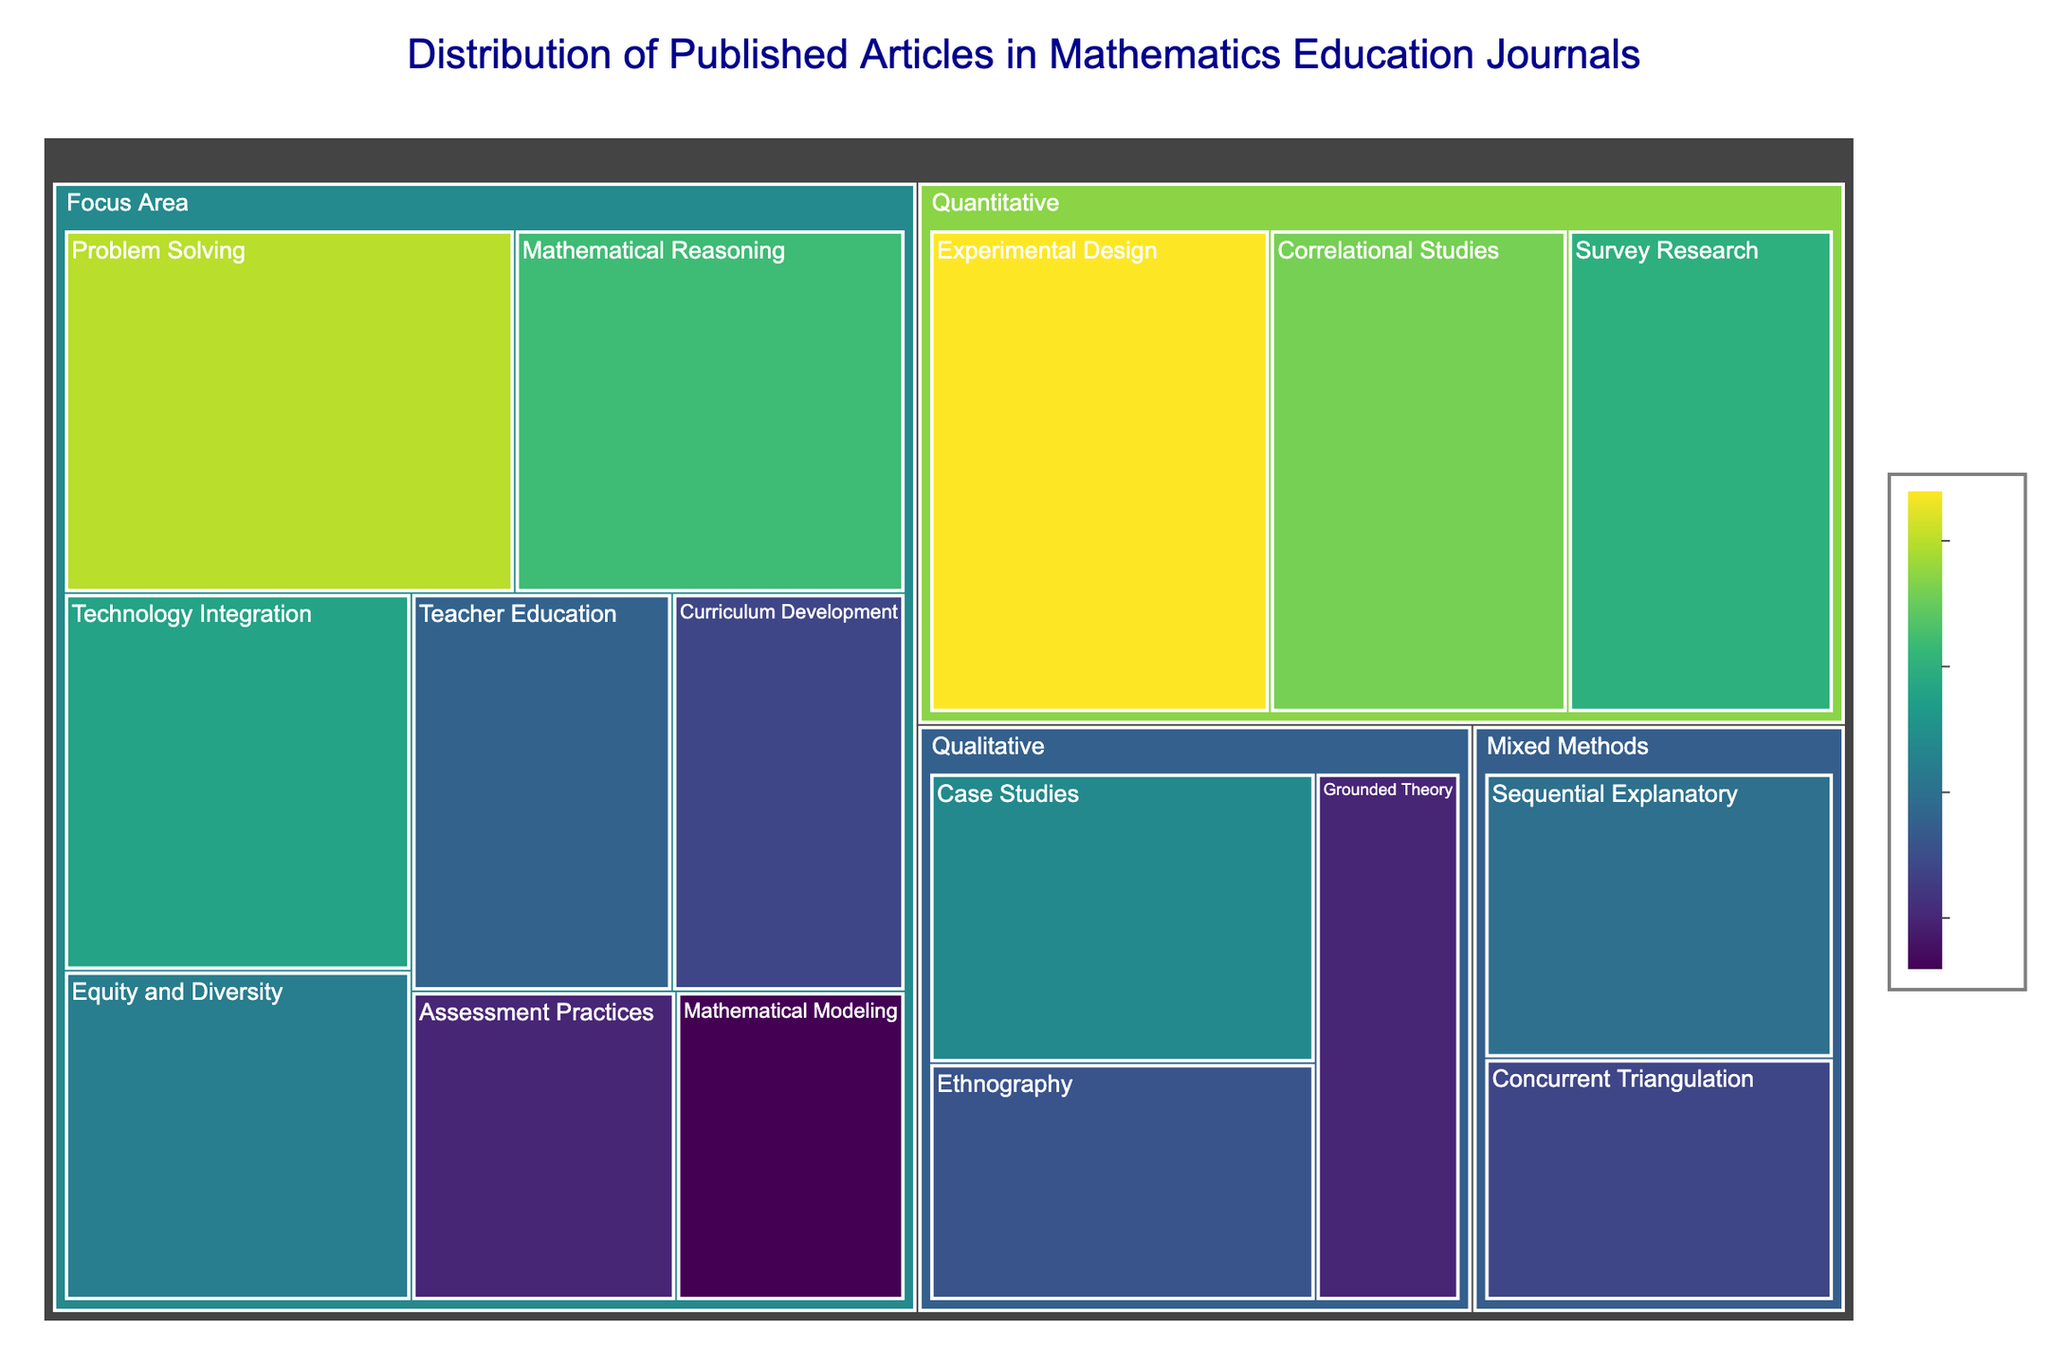What is the main title of the treemap? The main title is displayed at the top of the treemap in large font. It provides the overall description of the data presented.
Answer: Distribution of Published Articles in Mathematics Education Journals Which research methodology category has the highest number of published articles? By observing the segment size in the treemap, the category with the largest segment will have the highest number of articles.
Answer: Quantitative How many articles have been published in the "Case Studies" subcategory? Refer to the segment labeled "Case Studies" and check the number displayed.
Answer: 22 Which focus area has the least number of published articles? The focus area with the smallest segment will have the least number of articles.
Answer: Mathematical Modeling What is the combined total number of articles published in "Quantitative" research methodology subcategories? Sum values for all subcategories under Quantitative: 32 (Experimental Design) + 28 (Correlational Studies) + 25 (Survey Research).
Answer: 85 How many more articles are there in "Problem Solving" than in "Teacher Education"? Find the difference between the values for "Problem Solving" (30) and "Teacher Education" (19).
Answer: 11 Which subcategory under "Mixed Methods" has the highest number of published articles? Compare segment sizes under the Mixed Methods category to find the largest one.
Answer: Sequential Explanatory How does the number of articles in "Ethnography" compare to that in "Grounded Theory"? Check the values for "Ethnography" (18) and "Grounded Theory" (15), then determine which is higher.
Answer: Ethnography has 3 more articles than Grounded Theory What is the average number of articles published in the subcategories of "Qualitative" research methodology? Sum the values for categories under Qualitative (22 + 18 + 15) and divide by the number of subcategories (3).
Answer: 18.33 How are the different focus areas represented color-wise on the treemap? Observe the color gradient used for the various segments corresponding to focus areas. The color represents the number of articles, following a continuous scale (like Viridis).
Answer: Color gradient (Viridis) varying by number of articles 